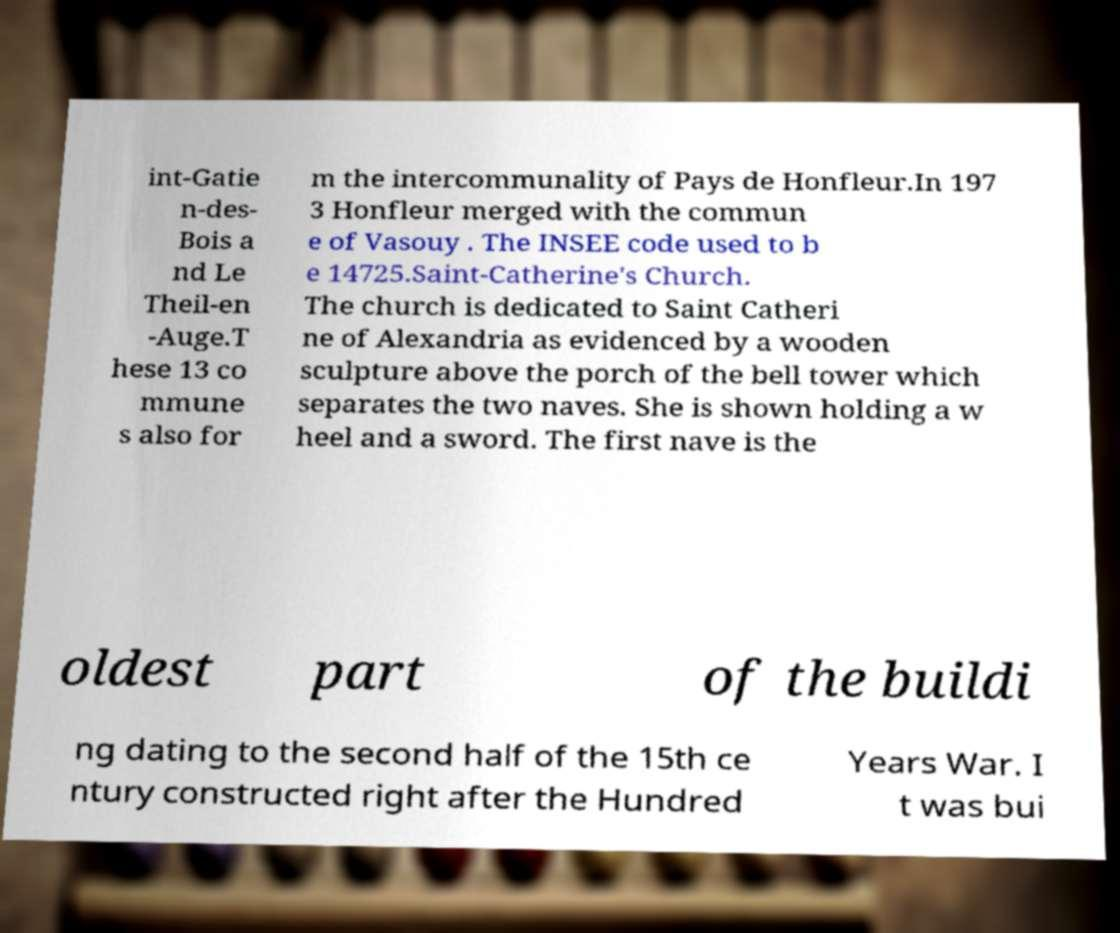Could you extract and type out the text from this image? int-Gatie n-des- Bois a nd Le Theil-en -Auge.T hese 13 co mmune s also for m the intercommunality of Pays de Honfleur.In 197 3 Honfleur merged with the commun e of Vasouy . The INSEE code used to b e 14725.Saint-Catherine's Church. The church is dedicated to Saint Catheri ne of Alexandria as evidenced by a wooden sculpture above the porch of the bell tower which separates the two naves. She is shown holding a w heel and a sword. The first nave is the oldest part of the buildi ng dating to the second half of the 15th ce ntury constructed right after the Hundred Years War. I t was bui 